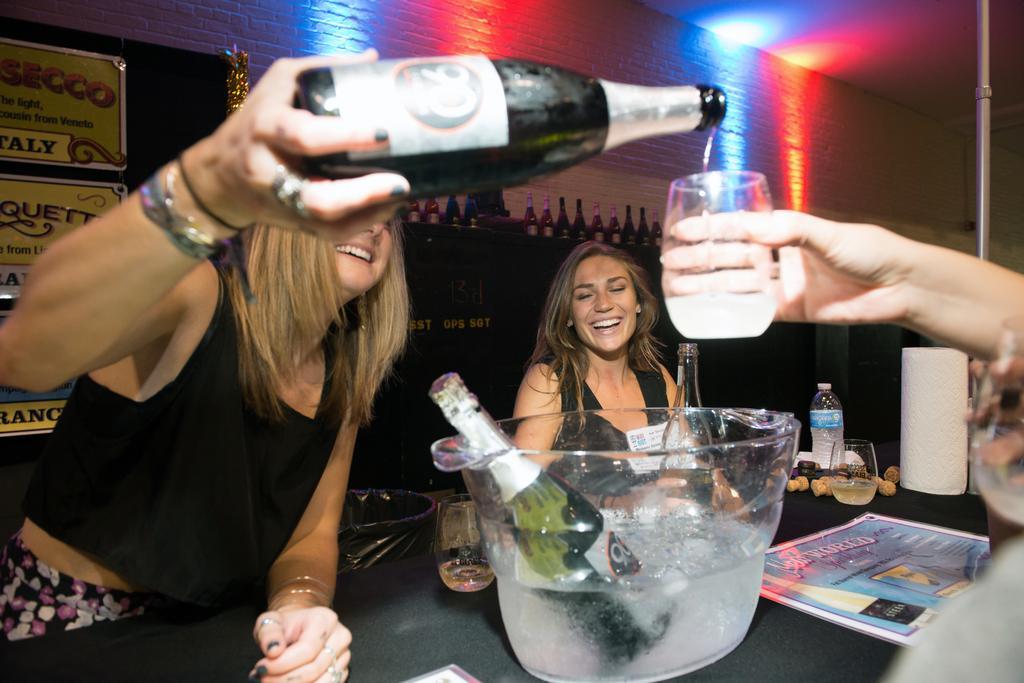Can you describe this image briefly? There is a woman on the left side. She is pouring a wine into the glass which is held by this hand. There is woman in the center and she is smiling. This looks like a table where a bottle, a glass and a wine bottle which is kept on a water tab are all kept on it. 